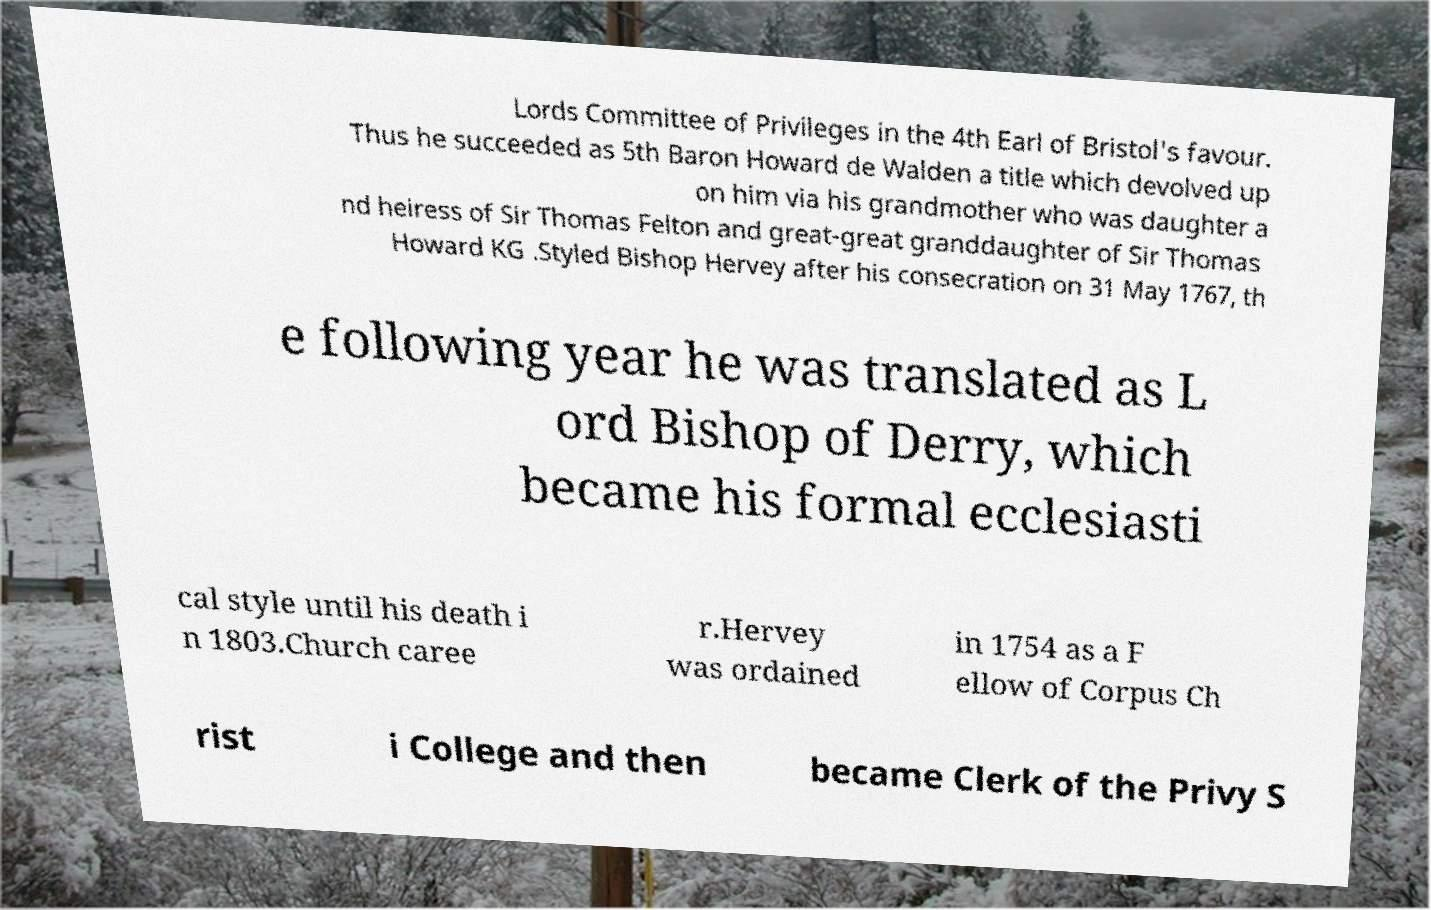There's text embedded in this image that I need extracted. Can you transcribe it verbatim? Lords Committee of Privileges in the 4th Earl of Bristol's favour. Thus he succeeded as 5th Baron Howard de Walden a title which devolved up on him via his grandmother who was daughter a nd heiress of Sir Thomas Felton and great-great granddaughter of Sir Thomas Howard KG .Styled Bishop Hervey after his consecration on 31 May 1767, th e following year he was translated as L ord Bishop of Derry, which became his formal ecclesiasti cal style until his death i n 1803.Church caree r.Hervey was ordained in 1754 as a F ellow of Corpus Ch rist i College and then became Clerk of the Privy S 